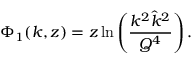Convert formula to latex. <formula><loc_0><loc_0><loc_500><loc_500>\Phi _ { 1 } ( k , z ) = z \ln \left ( \frac { k ^ { 2 } \hat { k } ^ { 2 } } { Q ^ { 4 } } \right ) .</formula> 